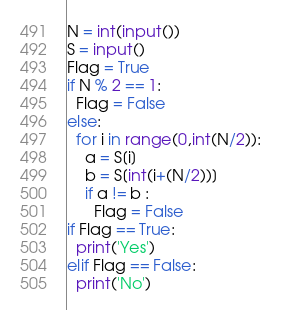<code> <loc_0><loc_0><loc_500><loc_500><_Python_>N = int(input())
S = input()
Flag = True
if N % 2 == 1:
  Flag = False
else:
  for i in range(0,int(N/2)):
    a = S[i]
    b = S[int(i+(N/2))]
    if a != b :
      Flag = False
if Flag == True:
  print('Yes')
elif Flag == False:
  print('No')
</code> 